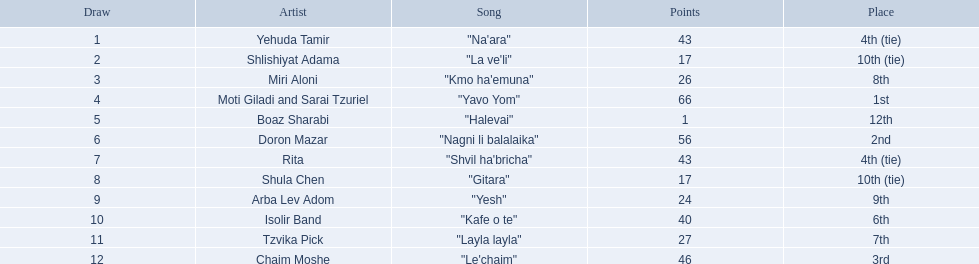How many artistic individuals exist? Yehuda Tamir, Shlishiyat Adama, Miri Aloni, Moti Giladi and Sarai Tzuriel, Boaz Sharabi, Doron Mazar, Rita, Shula Chen, Arba Lev Adom, Isolir Band, Tzvika Pick, Chaim Moshe. What is the smallest sum of points bestowed? 1. Who was the artist receiving those points? Boaz Sharabi. What position did the participant with just one point achieve? 12th. What was the name of the artist mentioned earlier? Boaz Sharabi. 